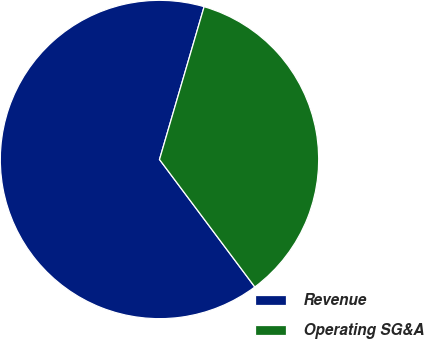Convert chart. <chart><loc_0><loc_0><loc_500><loc_500><pie_chart><fcel>Revenue<fcel>Operating SG&A<nl><fcel>64.74%<fcel>35.26%<nl></chart> 